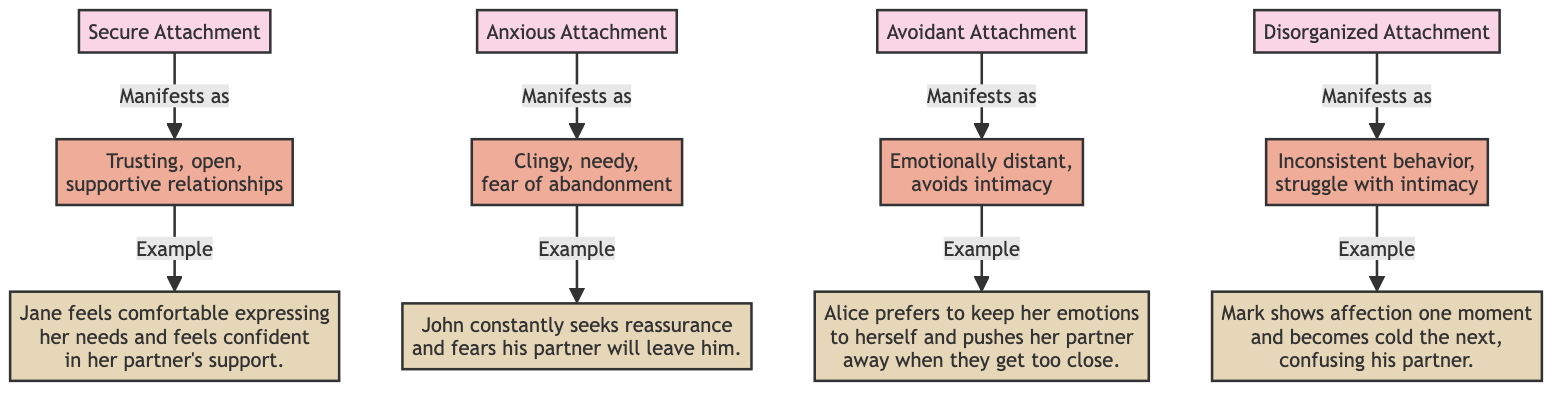What are the four attachment styles listed in the diagram? The diagram clearly labels four distinct attachment styles: Secure, Anxious, Avoidant, and Disorganized. These styles are prominently displayed at the top of the flowchart.
Answer: Secure, Anxious, Avoidant, Disorganized How many manifestations of attachment styles are there in the diagram? The diagram outlines one manifestation for each of the four attachment styles, totaling four manifestations. Each attachment type has one corresponding behavior pattern listed beneath it.
Answer: Four Which attachment style manifests as "Clingy, needy, fear of abandonment"? The description "Clingy, needy, fear of abandonment" is explicitly linked to the Anxious Attachment style in the diagram. This connection is made through flow arrows indicating how each style manifests in behavior.
Answer: Anxious Attachment What type of behavior does a Disorganized attachment style typically exhibit? The Disorganized attachment style is illustrated as showing "Inconsistent behavior, struggle with intimacy," indicating difficulties in maintaining stable relational patterns. This information is directly linked from the Disorganized node in the diagram.
Answer: Inconsistent behavior, struggle with intimacy What is an example scenario for someone with a Secure attachment? The example scenario provided for Secure attachment is that "Jane feels comfortable expressing her needs and feels confident in her partner's support." This matches directly with the corresponding manifestation for Secure attachment.
Answer: Jane feels comfortable expressing her needs and feels confident in her partner's support Which attachment style is characterized by an emotional distance? The diagram indicates that Avoidant Attachment is characterized by "Emotionally distant, avoids intimacy." This direct relationship is established from the Avoidant node to its manifestation.
Answer: Avoidant Attachment 